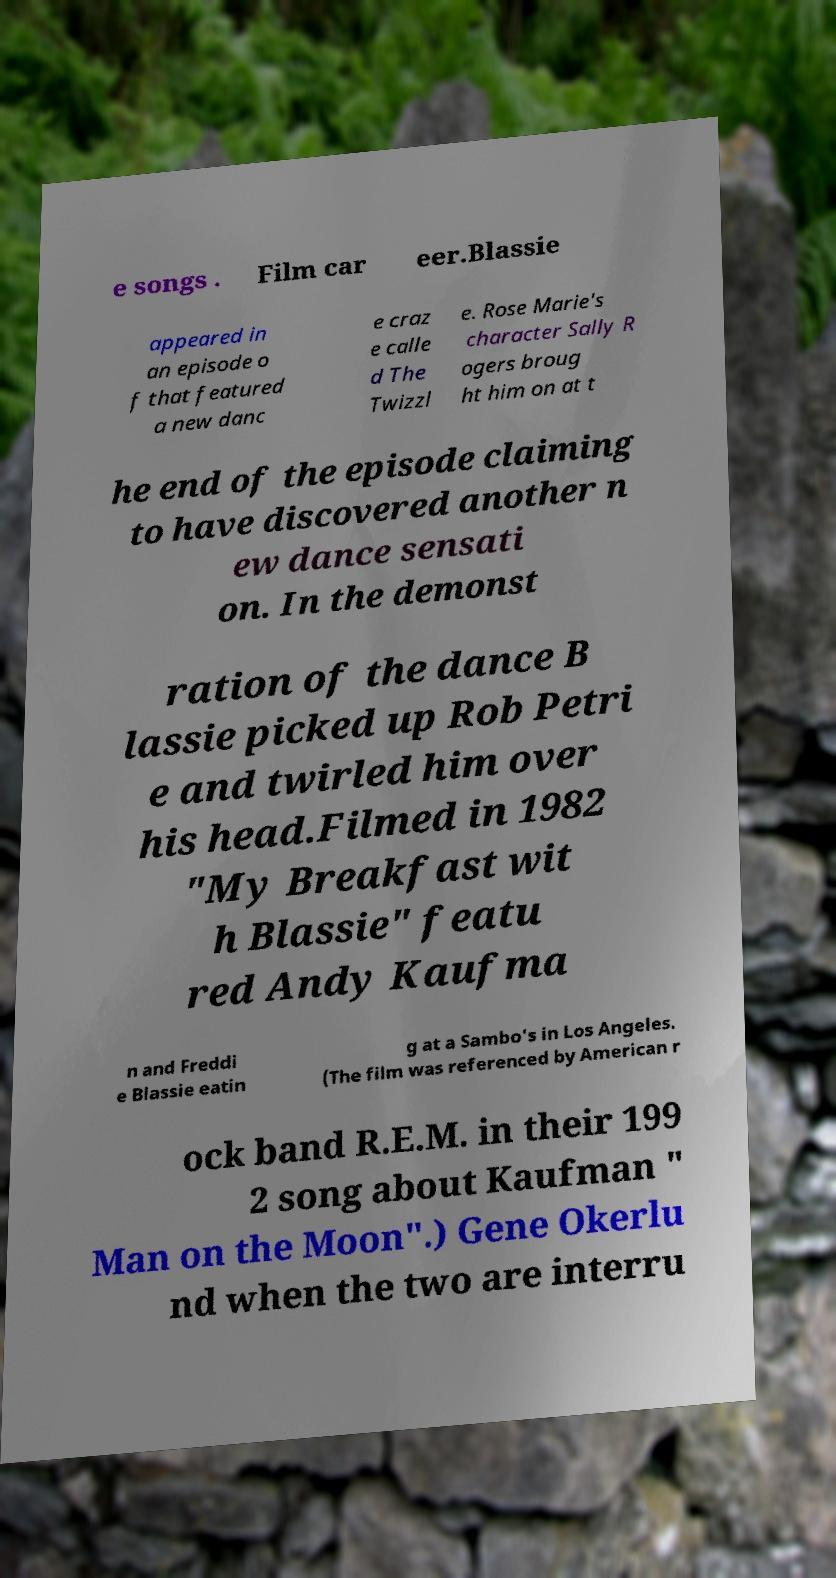What messages or text are displayed in this image? I need them in a readable, typed format. e songs . Film car eer.Blassie appeared in an episode o f that featured a new danc e craz e calle d The Twizzl e. Rose Marie's character Sally R ogers broug ht him on at t he end of the episode claiming to have discovered another n ew dance sensati on. In the demonst ration of the dance B lassie picked up Rob Petri e and twirled him over his head.Filmed in 1982 "My Breakfast wit h Blassie" featu red Andy Kaufma n and Freddi e Blassie eatin g at a Sambo's in Los Angeles. (The film was referenced by American r ock band R.E.M. in their 199 2 song about Kaufman " Man on the Moon".) Gene Okerlu nd when the two are interru 